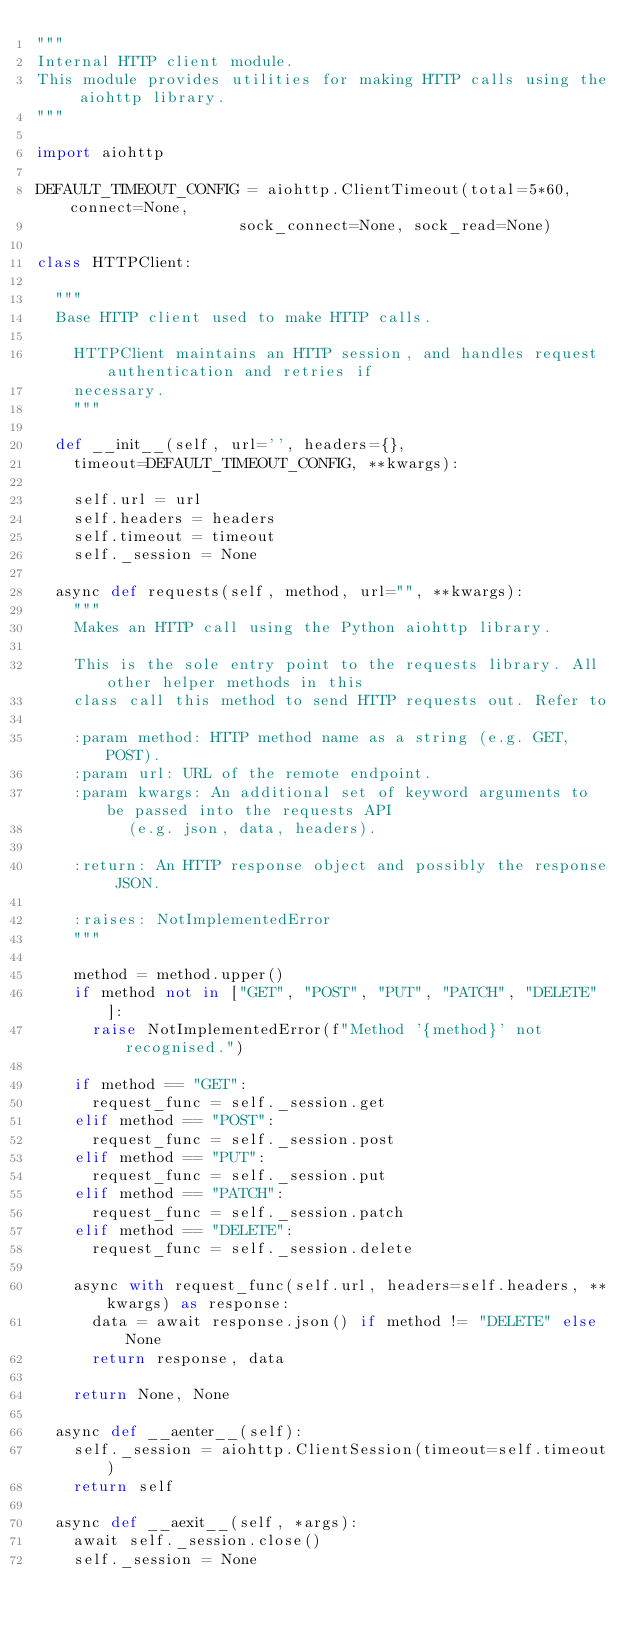<code> <loc_0><loc_0><loc_500><loc_500><_Python_>"""
Internal HTTP client module.
This module provides utilities for making HTTP calls using the aiohttp library.
"""

import aiohttp

DEFAULT_TIMEOUT_CONFIG = aiohttp.ClientTimeout(total=5*60, connect=None,
                      sock_connect=None, sock_read=None)

class HTTPClient:

	"""
	Base HTTP client used to make HTTP calls.

    HTTPClient maintains an HTTP session, and handles request authentication and retries if
    necessary.
    """

	def __init__(self, url='', headers={},
		timeout=DEFAULT_TIMEOUT_CONFIG, **kwargs):

		self.url = url
		self.headers = headers
		self.timeout = timeout
		self._session = None

	async def requests(self, method, url="", **kwargs):
		"""
		Makes an HTTP call using the Python aiohttp library.

		This is the sole entry point to the requests library. All other helper methods in this
		class call this method to send HTTP requests out. Refer to

		:param method: HTTP method name as a string (e.g. GET, POST).
		:param url: URL of the remote endpoint.
		:param kwargs: An additional set of keyword arguments to be passed into the requests API
		      (e.g. json, data, headers).

		:return: An HTTP response object and possibly the response JSON.

		:raises: NotImplementedError
		"""

		method = method.upper()
		if method not in ["GET", "POST", "PUT", "PATCH", "DELETE"]:
			raise NotImplementedError(f"Method '{method}' not recognised.")

		if method == "GET":
			request_func = self._session.get
		elif method == "POST":
			request_func = self._session.post
		elif method == "PUT":
			request_func = self._session.put
		elif method == "PATCH":
			request_func = self._session.patch
		elif method == "DELETE":
			request_func = self._session.delete

		async with request_func(self.url, headers=self.headers, **kwargs) as response:
			data = await response.json() if method != "DELETE" else None
			return response, data

		return None, None

	async def __aenter__(self):
		self._session = aiohttp.ClientSession(timeout=self.timeout)
		return self

	async def __aexit__(self, *args):
		await self._session.close()
		self._session = None</code> 